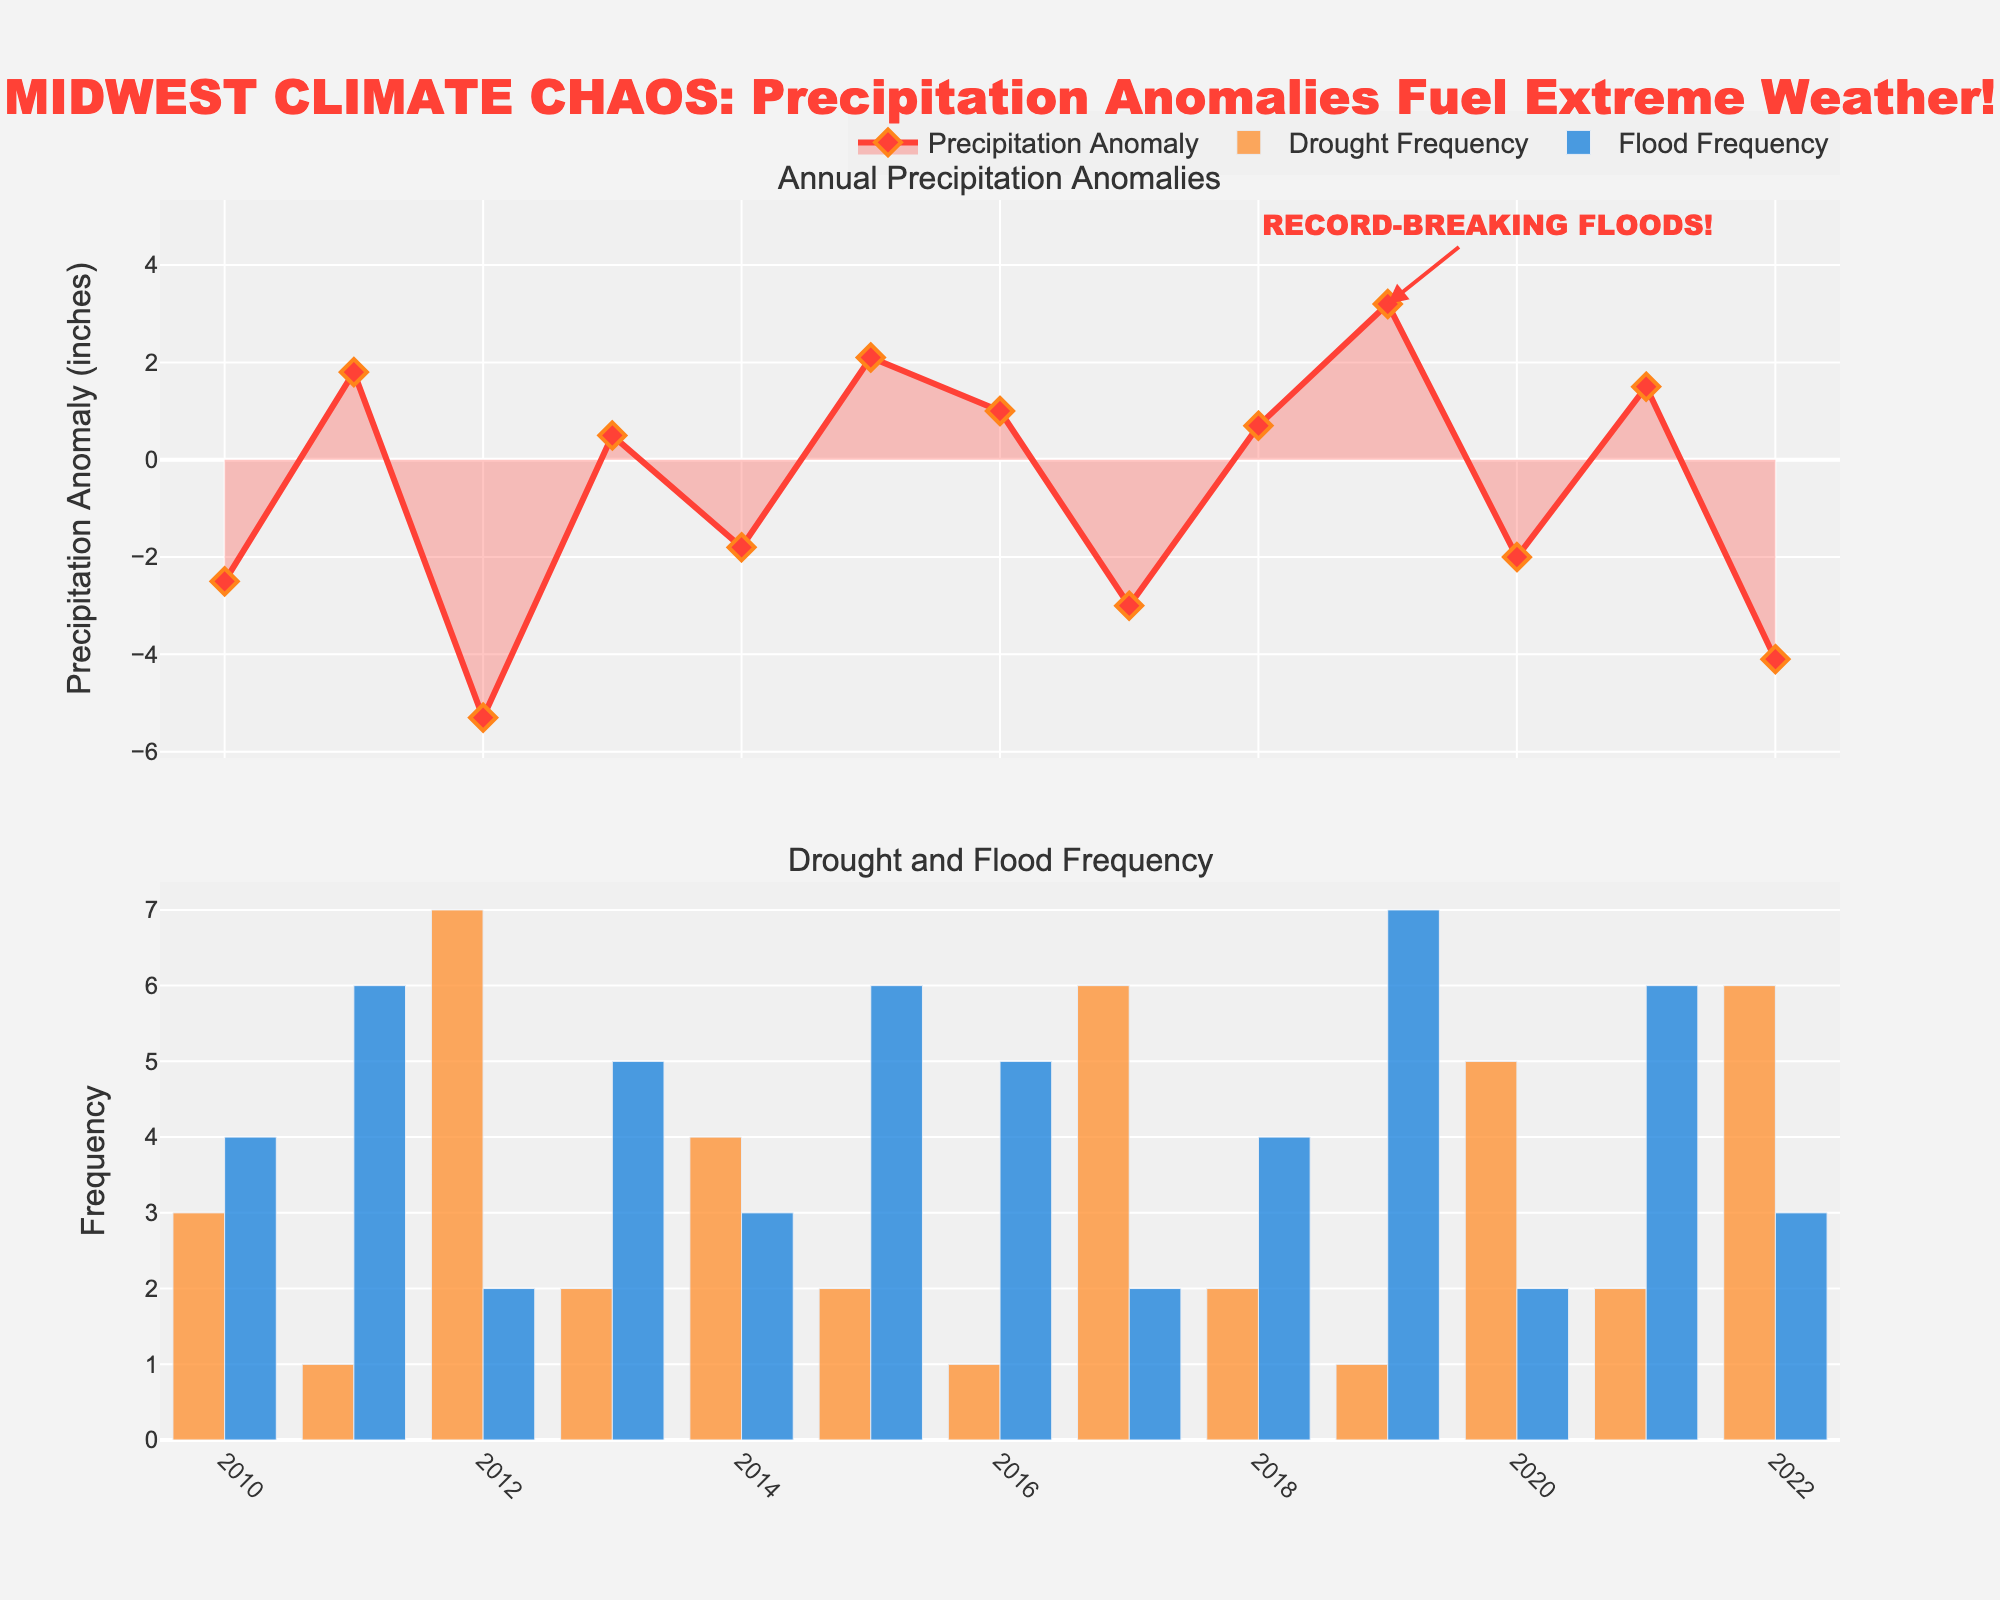What's the title of the figure? The title of the figure is usually located at the top and summarizes the main theme of the data visualization.
Answer: MIDWEST CLIMATE CHAOS: Precipitation Anomalies Fuel Extreme Weather! How many years of data are presented in the figure? Count the number of years listed on the x-axis. Each year is marked from 2010 to 2022.
Answer: 13 What is the maximum precipitation anomaly recorded in the dataset, and in which year did it occur? Identify the peak value on the "Annual Precipitation Anomalies" plot. The highest value is 3.2 inches, which happens in the year 2019.
Answer: 3.2 inches, 2019 Which year experienced the highest frequency of major droughts? Look for the tallest bar in the "Drought Frequency" chart. The highest frequency of major droughts is 7, which occurs in 2012.
Answer: 2012 What is the trend in flood frequency from 2010 to 2022? Observe the "Flood Frequency" bar chart to analyze if the bars are generally increasing, decreasing, or fluctuating over the years. While there are fluctuations, there is no clear, consistent trend.
Answer: Fluctuating How does the drought frequency in 2012 compare to the flood frequency in the same year? Identify the values for drought and flood frequencies in 2012. Drought frequency is 7, and flood frequency is 2.
Answer: Drought frequency is higher In which year do we see record-breaking floods, according to the annotation in the plot? Check for annotation text in the plot. It mentions "RECORD-BREAKING FLOODS" at the year 2019.
Answer: 2019 Compare the difference in drought frequencies between 2017 and 2019. Identify the frequencies in both years and calculate the difference. In 2017, the frequency is 6 and in 2019, it is 1. So the difference is 6 - 1 = 5.
Answer: 5 What is the average precipitation anomaly from 2010 to 2022? Sum all the precipitation anomalies from 2010 to 2022 and divide by the total number of years (13). (-2.5 + 1.8 - 5.3 + 0.5 - 1.8 + 2.1 + 1.0 - 3.0 + 0.7 + 3.2 -2.0 + 1.5 - 4.1) / 13 = -0.154 inches
Answer: -0.154 inches How did the precipitation anomaly in 2022 correlate with the frequency of droughts and floods? Note the values for precipitation anomaly, drought frequency, and flood frequency for the year 2022. Precipitation anomaly is -4.1, drought frequency is 6, and flood frequency is 3. Negative anomaly correlates with more droughts and fewer floods.
Answer: More droughts, fewer floods 